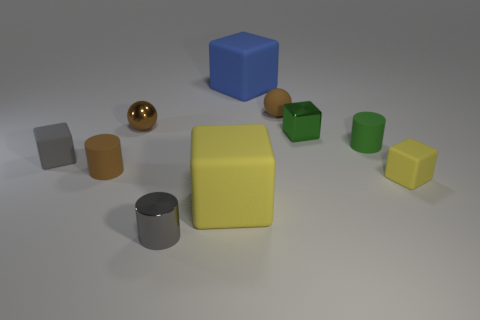Subtract all brown spheres. How many yellow cubes are left? 2 Subtract all green cubes. How many cubes are left? 4 Subtract all rubber cylinders. How many cylinders are left? 1 Subtract 1 cylinders. How many cylinders are left? 2 Subtract all green cubes. Subtract all brown spheres. How many cubes are left? 4 Subtract all balls. How many objects are left? 8 Add 8 brown rubber spheres. How many brown rubber spheres exist? 9 Subtract 1 gray cubes. How many objects are left? 9 Subtract all yellow blocks. Subtract all big rubber cubes. How many objects are left? 6 Add 2 tiny brown objects. How many tiny brown objects are left? 5 